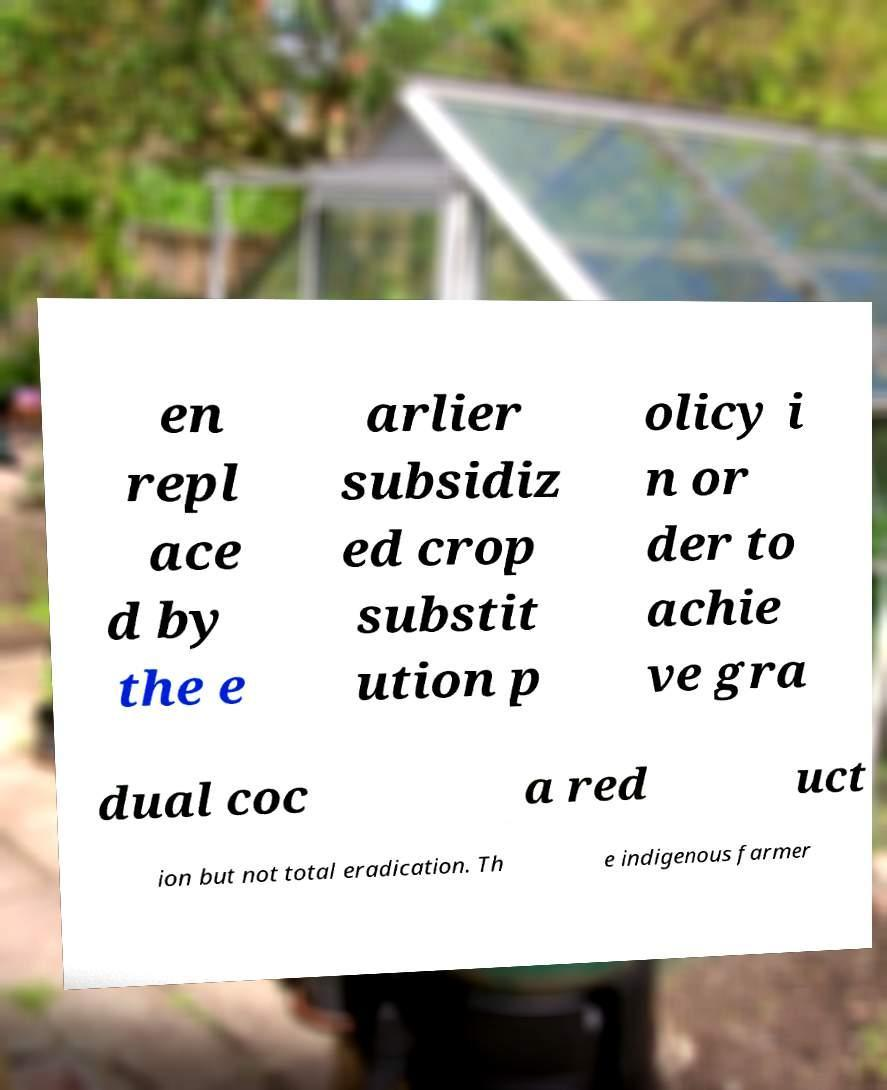There's text embedded in this image that I need extracted. Can you transcribe it verbatim? en repl ace d by the e arlier subsidiz ed crop substit ution p olicy i n or der to achie ve gra dual coc a red uct ion but not total eradication. Th e indigenous farmer 